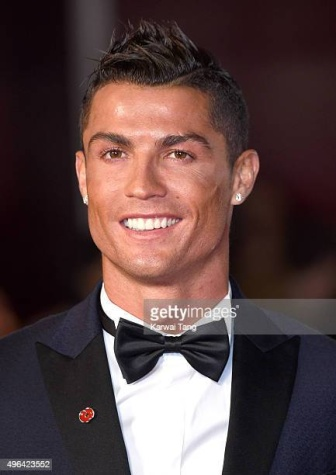Can you elaborate on the elements of the picture provided? The image features Cristiano Ronaldo at a glamorous red carpet event. He is impeccably dressed in a classic tuxedo, consisting of a black jacket, trousers, and a tailored white shirt, paired with a polished black bow tie. Notably, his look is accented with a vibrant red flower pinned on his lapel, adding a touch of color and sophistication. His bright smile and direct gaze toward something out of the frame suggest he is engaged and possibly interacting with event attendees or media. The background, though blurred, hints at a bustling event atmosphere with lights and a gathered crowd. This setting underscores the blend of personal charm and public appeal characteristic of Ronaldo's appearances at such high-profile events. 